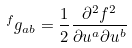<formula> <loc_0><loc_0><loc_500><loc_500>\ ^ { f } g _ { a b } = \frac { 1 } { 2 } \frac { \partial ^ { 2 } f ^ { 2 } } { \partial u ^ { a } \partial u ^ { b } }</formula> 